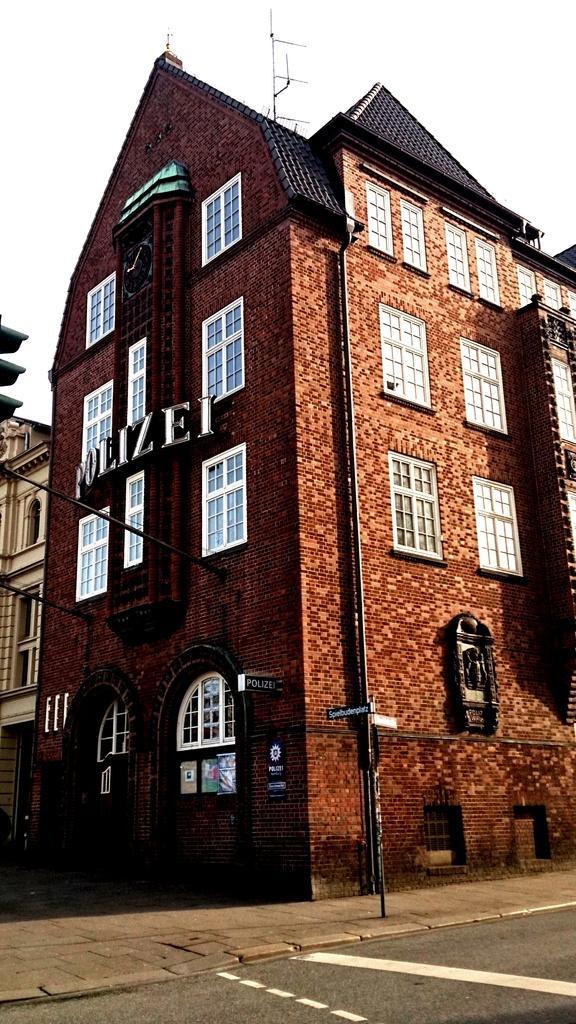Can you describe this image briefly? In this image we can see buildings, boards and poles attached to the building, traffic light, pavement, road and in the background there is sky. 